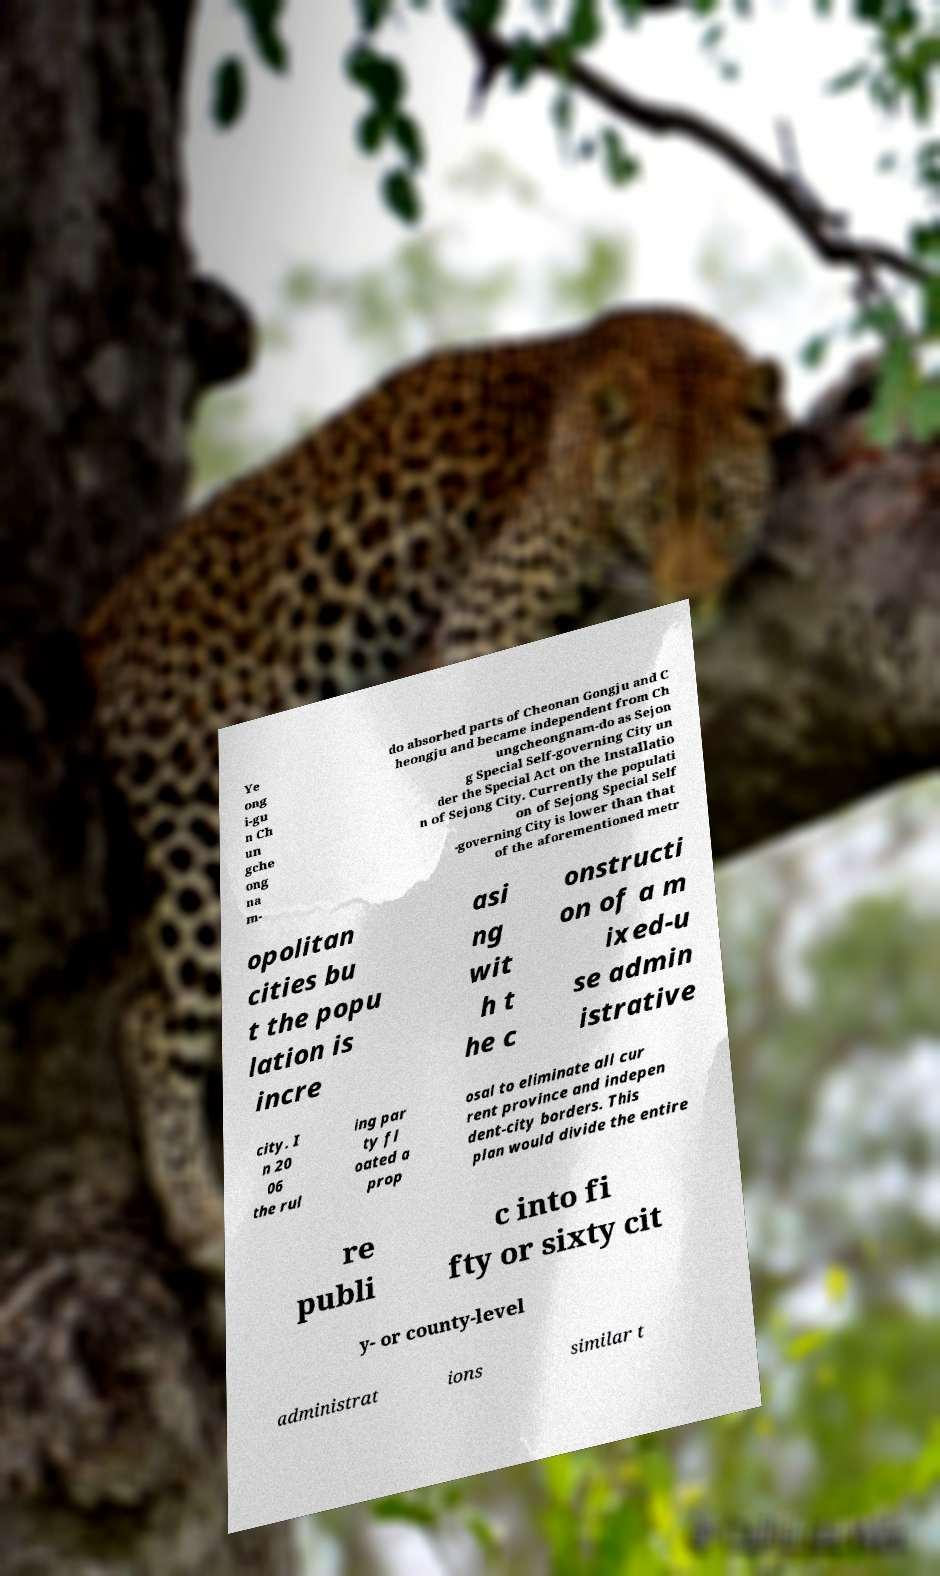I need the written content from this picture converted into text. Can you do that? Ye ong i-gu n Ch un gche ong na m- do absorbed parts of Cheonan Gongju and C heongju and became independent from Ch ungcheongnam-do as Sejon g Special Self-governing City un der the Special Act on the Installatio n of Sejong City. Currently the populati on of Sejong Special Self -governing City is lower than that of the aforementioned metr opolitan cities bu t the popu lation is incre asi ng wit h t he c onstructi on of a m ixed-u se admin istrative city. I n 20 06 the rul ing par ty fl oated a prop osal to eliminate all cur rent province and indepen dent-city borders. This plan would divide the entire re publi c into fi fty or sixty cit y- or county-level administrat ions similar t 